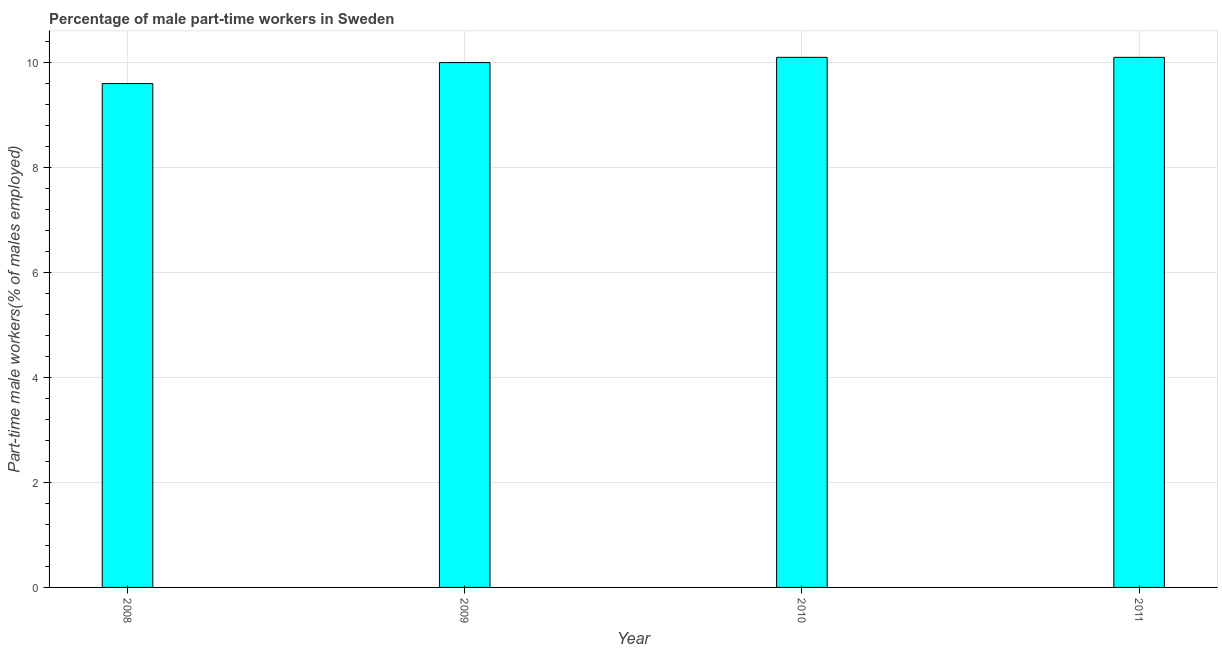Does the graph contain grids?
Offer a terse response. Yes. What is the title of the graph?
Your answer should be very brief. Percentage of male part-time workers in Sweden. What is the label or title of the Y-axis?
Your response must be concise. Part-time male workers(% of males employed). What is the percentage of part-time male workers in 2008?
Offer a terse response. 9.6. Across all years, what is the maximum percentage of part-time male workers?
Your answer should be very brief. 10.1. Across all years, what is the minimum percentage of part-time male workers?
Your answer should be compact. 9.6. In which year was the percentage of part-time male workers minimum?
Your response must be concise. 2008. What is the sum of the percentage of part-time male workers?
Your response must be concise. 39.8. What is the difference between the percentage of part-time male workers in 2009 and 2011?
Ensure brevity in your answer.  -0.1. What is the average percentage of part-time male workers per year?
Ensure brevity in your answer.  9.95. What is the median percentage of part-time male workers?
Your response must be concise. 10.05. In how many years, is the percentage of part-time male workers greater than 4.4 %?
Keep it short and to the point. 4. Do a majority of the years between 2009 and 2010 (inclusive) have percentage of part-time male workers greater than 5.2 %?
Your answer should be compact. Yes. What is the ratio of the percentage of part-time male workers in 2008 to that in 2009?
Your answer should be very brief. 0.96. Is the percentage of part-time male workers in 2008 less than that in 2011?
Your answer should be compact. Yes. Is the difference between the percentage of part-time male workers in 2009 and 2010 greater than the difference between any two years?
Your answer should be compact. No. What is the difference between the highest and the second highest percentage of part-time male workers?
Offer a very short reply. 0. Is the sum of the percentage of part-time male workers in 2009 and 2011 greater than the maximum percentage of part-time male workers across all years?
Offer a very short reply. Yes. What is the difference between the highest and the lowest percentage of part-time male workers?
Make the answer very short. 0.5. Are all the bars in the graph horizontal?
Provide a short and direct response. No. How many years are there in the graph?
Provide a succinct answer. 4. What is the difference between two consecutive major ticks on the Y-axis?
Give a very brief answer. 2. What is the Part-time male workers(% of males employed) of 2008?
Provide a short and direct response. 9.6. What is the Part-time male workers(% of males employed) of 2009?
Ensure brevity in your answer.  10. What is the Part-time male workers(% of males employed) in 2010?
Your response must be concise. 10.1. What is the Part-time male workers(% of males employed) of 2011?
Offer a very short reply. 10.1. What is the difference between the Part-time male workers(% of males employed) in 2008 and 2009?
Provide a short and direct response. -0.4. What is the difference between the Part-time male workers(% of males employed) in 2008 and 2011?
Your response must be concise. -0.5. What is the difference between the Part-time male workers(% of males employed) in 2009 and 2010?
Provide a succinct answer. -0.1. What is the difference between the Part-time male workers(% of males employed) in 2010 and 2011?
Give a very brief answer. 0. What is the ratio of the Part-time male workers(% of males employed) in 2008 to that in 2010?
Keep it short and to the point. 0.95. What is the ratio of the Part-time male workers(% of males employed) in 2009 to that in 2010?
Keep it short and to the point. 0.99. 